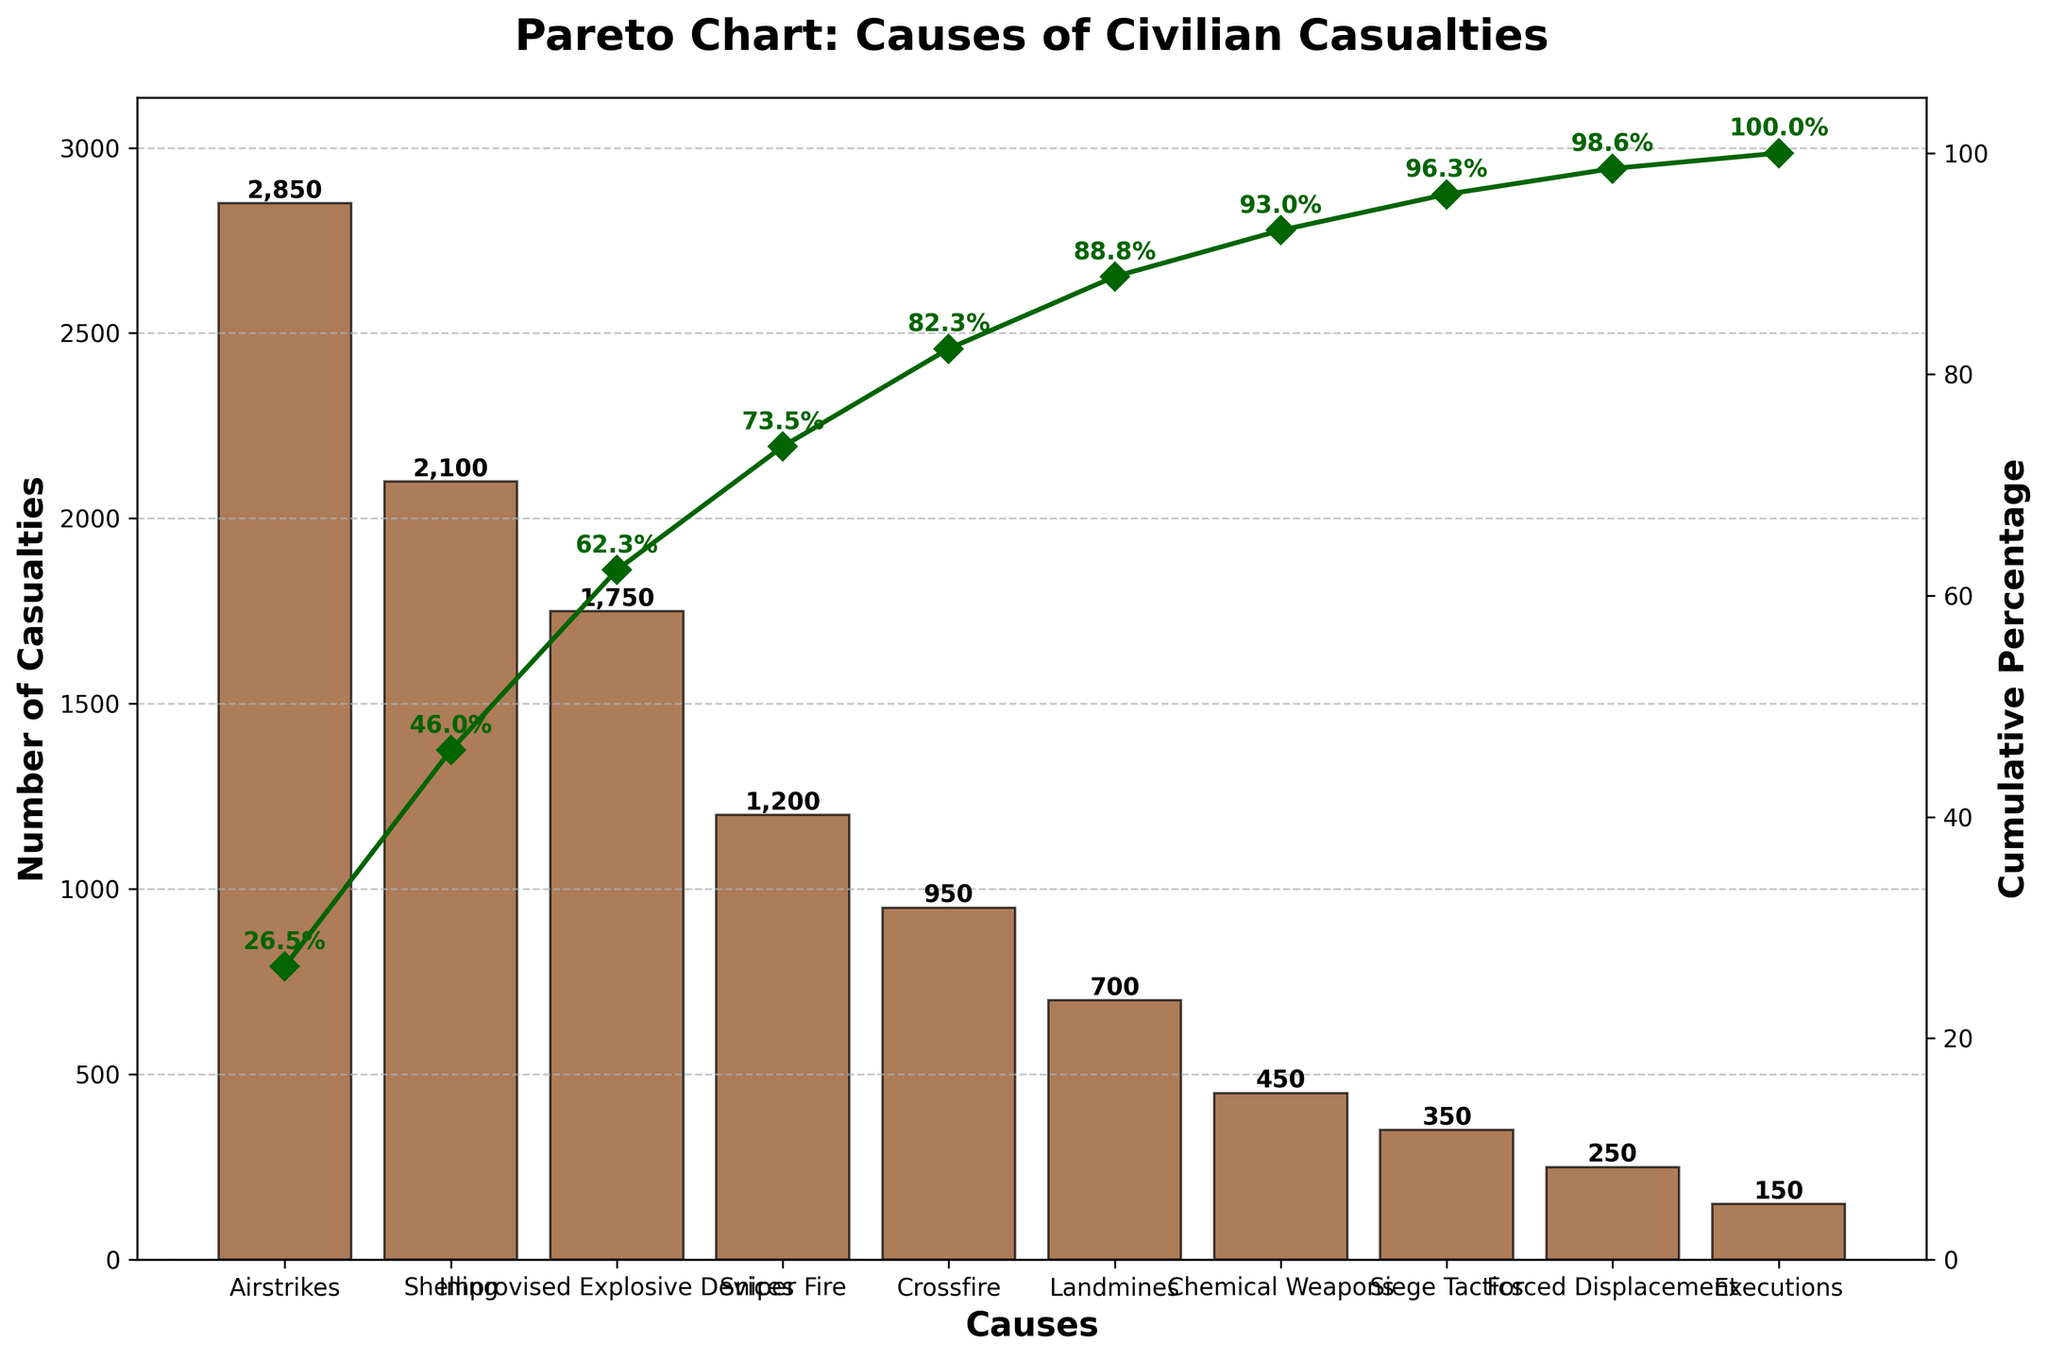What is the title of the figure? The title of the figure can be found at the top center of the plot. It provides a summary of what the figure is about. Observing the plot, the title is "Pareto Chart: Causes of Civilian Casualties."
Answer: Pareto Chart: Causes of Civilian Casualties Which cause of civilian casualties has the highest frequency? The most frequent cause is represented by the tallest bar on the Pareto chart. Observing the bars, the one representing "Airstrikes" is the tallest.
Answer: Airstrikes What is the cumulative percentage for the top two causes? The cumulative percentage is represented by the line chart. For the top two causes ("Airstrikes" and "Shelling"), look for their percentages on the line. The cumulative percentages are around 32.2% for "Airstrikes" and 56.0% for "Shelling".
Answer: 56.0% How many casualties were caused by Improvised Explosive Devices? Each bar in the chart shows the number of casualties. For "Improvised Explosive Devices," locate its respective bar and refer to the label above it. It shows 1,750 casualties.
Answer: 1,750 What is the combined total of casualties from Sniper Fire and Crossfire? Find the number of casualties for both "Sniper Fire" and "Crossfire". Add them together: 1,200 + 950 = 2,150.
Answer: 2,150 Which causes, when combined, account for more than 75% of the casualties? Look at the cumulative percentage line and identify the causes up to the 75% mark. The causes "Airstrikes," "Shelling," "Improvised Explosive Devices," and "Sniper Fire" contribute more than 75%.
Answer: Airstrikes, Shelling, Improvised Explosive Devices, Sniper Fire What visual elements are used to distinguish the bars and the cumulative percentage line? The bars are visually distinguished by their color (brown) and edge color (black), whereas the cumulative percentage line is shown in green with diamond markers.
Answer: Color and markers What is the total number of civilian casualties represented in the chart? The total can be calculated by summing the number of casualties from each cause. Summing them gives 2850+2100+1750+1200+950+700+450+350+250+150 = 10,750.
Answer: 10,750 What is the percentage of casualties caused by Chemical Weapons? For the exact percentage, divide the number of casualties caused by Chemical Weapons by the total number of casualties and multiply by 100. 450 / 10,750 * 100 ≈ 4.2%.
Answer: 4.2% How does the figure distinguish between the left and right y-axes? The left y-axis measures the number of casualties and is associated with the bars, while the right y-axis measures the cumulative percentage and is associated with the line. Different colors and axis titles differentiate them.
Answer: Different colors and titles 